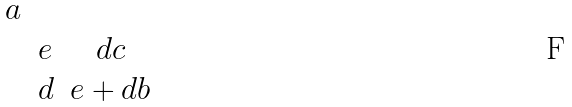<formula> <loc_0><loc_0><loc_500><loc_500>\begin{matrix} a & & \\ & e & d c \\ & d & e + d b \end{matrix}</formula> 